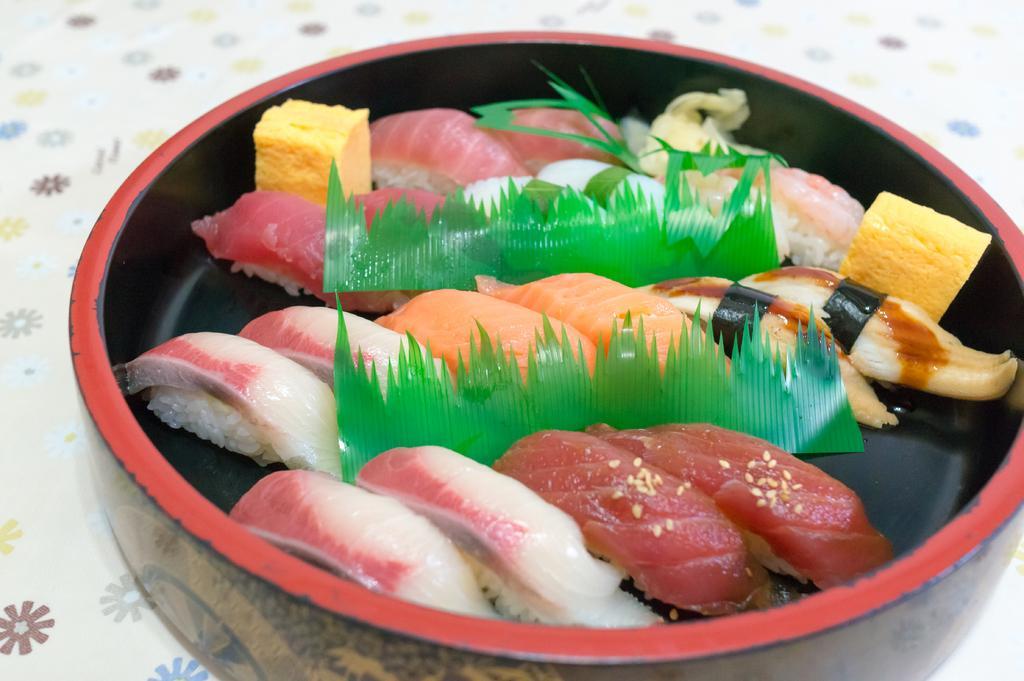How would you summarize this image in a sentence or two? In this picture we can see food in a bowl and this bowl is on the platform. 